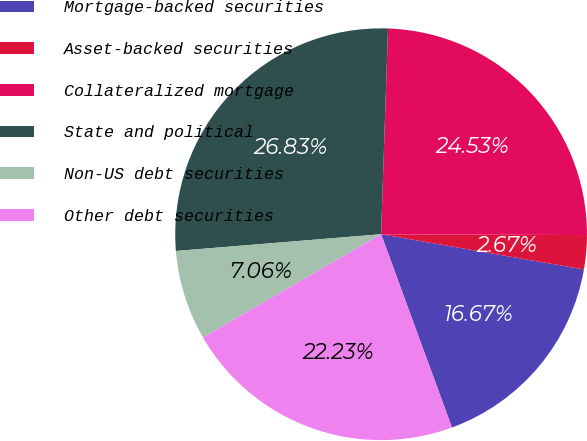Convert chart to OTSL. <chart><loc_0><loc_0><loc_500><loc_500><pie_chart><fcel>Mortgage-backed securities<fcel>Asset-backed securities<fcel>Collateralized mortgage<fcel>State and political<fcel>Non-US debt securities<fcel>Other debt securities<nl><fcel>16.67%<fcel>2.67%<fcel>24.53%<fcel>26.83%<fcel>7.06%<fcel>22.23%<nl></chart> 